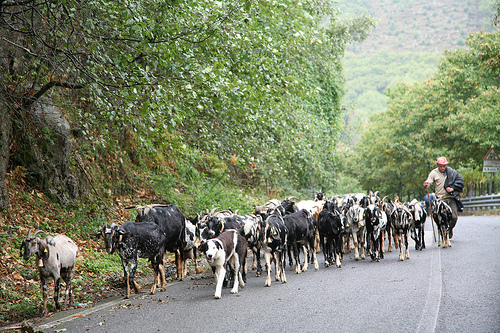<image>
Is there a man behind the goat? Yes. From this viewpoint, the man is positioned behind the goat, with the goat partially or fully occluding the man. 